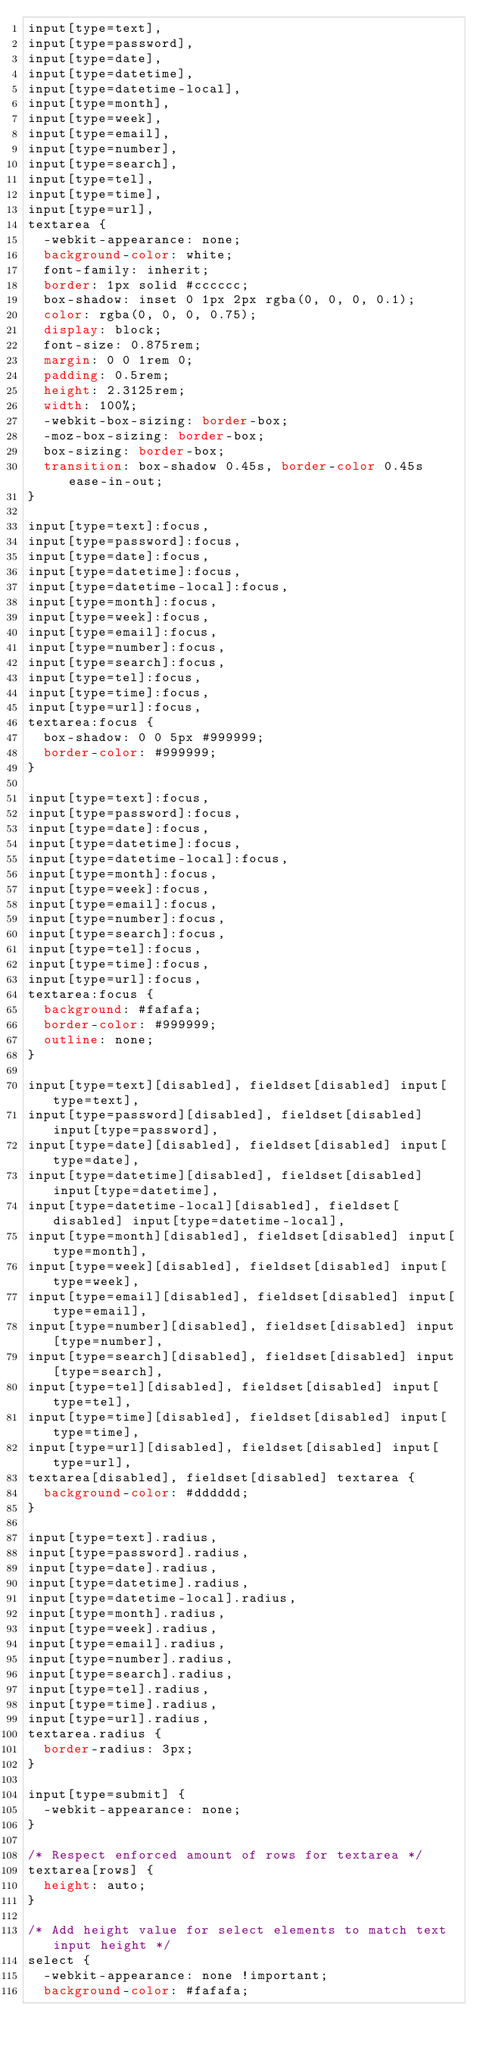Convert code to text. <code><loc_0><loc_0><loc_500><loc_500><_CSS_>input[type=text],
input[type=password],
input[type=date],
input[type=datetime],
input[type=datetime-local],
input[type=month],
input[type=week],
input[type=email],
input[type=number],
input[type=search],
input[type=tel],
input[type=time],
input[type=url],
textarea {
  -webkit-appearance: none;
  background-color: white;
  font-family: inherit;
  border: 1px solid #cccccc;
  box-shadow: inset 0 1px 2px rgba(0, 0, 0, 0.1);
  color: rgba(0, 0, 0, 0.75);
  display: block;
  font-size: 0.875rem;
  margin: 0 0 1rem 0;
  padding: 0.5rem;
  height: 2.3125rem;
  width: 100%;
  -webkit-box-sizing: border-box;
  -moz-box-sizing: border-box;
  box-sizing: border-box;
  transition: box-shadow 0.45s, border-color 0.45s ease-in-out;
}

input[type=text]:focus,
input[type=password]:focus,
input[type=date]:focus,
input[type=datetime]:focus,
input[type=datetime-local]:focus,
input[type=month]:focus,
input[type=week]:focus,
input[type=email]:focus,
input[type=number]:focus,
input[type=search]:focus,
input[type=tel]:focus,
input[type=time]:focus,
input[type=url]:focus,
textarea:focus {
  box-shadow: 0 0 5px #999999;
  border-color: #999999;
}

input[type=text]:focus,
input[type=password]:focus,
input[type=date]:focus,
input[type=datetime]:focus,
input[type=datetime-local]:focus,
input[type=month]:focus,
input[type=week]:focus,
input[type=email]:focus,
input[type=number]:focus,
input[type=search]:focus,
input[type=tel]:focus,
input[type=time]:focus,
input[type=url]:focus,
textarea:focus {
  background: #fafafa;
  border-color: #999999;
  outline: none;
}

input[type=text][disabled], fieldset[disabled] input[type=text],
input[type=password][disabled], fieldset[disabled] input[type=password],
input[type=date][disabled], fieldset[disabled] input[type=date],
input[type=datetime][disabled], fieldset[disabled] input[type=datetime],
input[type=datetime-local][disabled], fieldset[disabled] input[type=datetime-local],
input[type=month][disabled], fieldset[disabled] input[type=month],
input[type=week][disabled], fieldset[disabled] input[type=week],
input[type=email][disabled], fieldset[disabled] input[type=email],
input[type=number][disabled], fieldset[disabled] input[type=number],
input[type=search][disabled], fieldset[disabled] input[type=search],
input[type=tel][disabled], fieldset[disabled] input[type=tel],
input[type=time][disabled], fieldset[disabled] input[type=time],
input[type=url][disabled], fieldset[disabled] input[type=url],
textarea[disabled], fieldset[disabled] textarea {
  background-color: #dddddd;
}

input[type=text].radius,
input[type=password].radius,
input[type=date].radius,
input[type=datetime].radius,
input[type=datetime-local].radius,
input[type=month].radius,
input[type=week].radius,
input[type=email].radius,
input[type=number].radius,
input[type=search].radius,
input[type=tel].radius,
input[type=time].radius,
input[type=url].radius,
textarea.radius {
  border-radius: 3px;
}

input[type=submit] {
  -webkit-appearance: none;
}

/* Respect enforced amount of rows for textarea */
textarea[rows] {
  height: auto;
}

/* Add height value for select elements to match text input height */
select {
  -webkit-appearance: none !important;
  background-color: #fafafa;</code> 